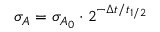<formula> <loc_0><loc_0><loc_500><loc_500>\sigma _ { A } = \sigma _ { A _ { 0 } } \cdot 2 ^ { - \Delta t / t _ { 1 / 2 } }</formula> 